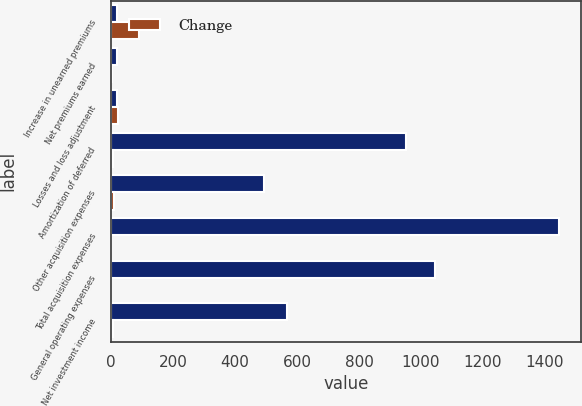<chart> <loc_0><loc_0><loc_500><loc_500><stacked_bar_chart><ecel><fcel>Increase in unearned premiums<fcel>Net premiums earned<fcel>Losses and loss adjustment<fcel>Amortization of deferred<fcel>Other acquisition expenses<fcel>Total acquisition expenses<fcel>General operating expenses<fcel>Net investment income<nl><fcel>nan<fcel>19<fcel>20<fcel>20<fcel>951<fcel>493<fcel>1444<fcel>1046<fcel>568<nl><fcel>Change<fcel>90<fcel>4<fcel>21<fcel>5<fcel>9<fcel>1<fcel>1<fcel>6<nl></chart> 